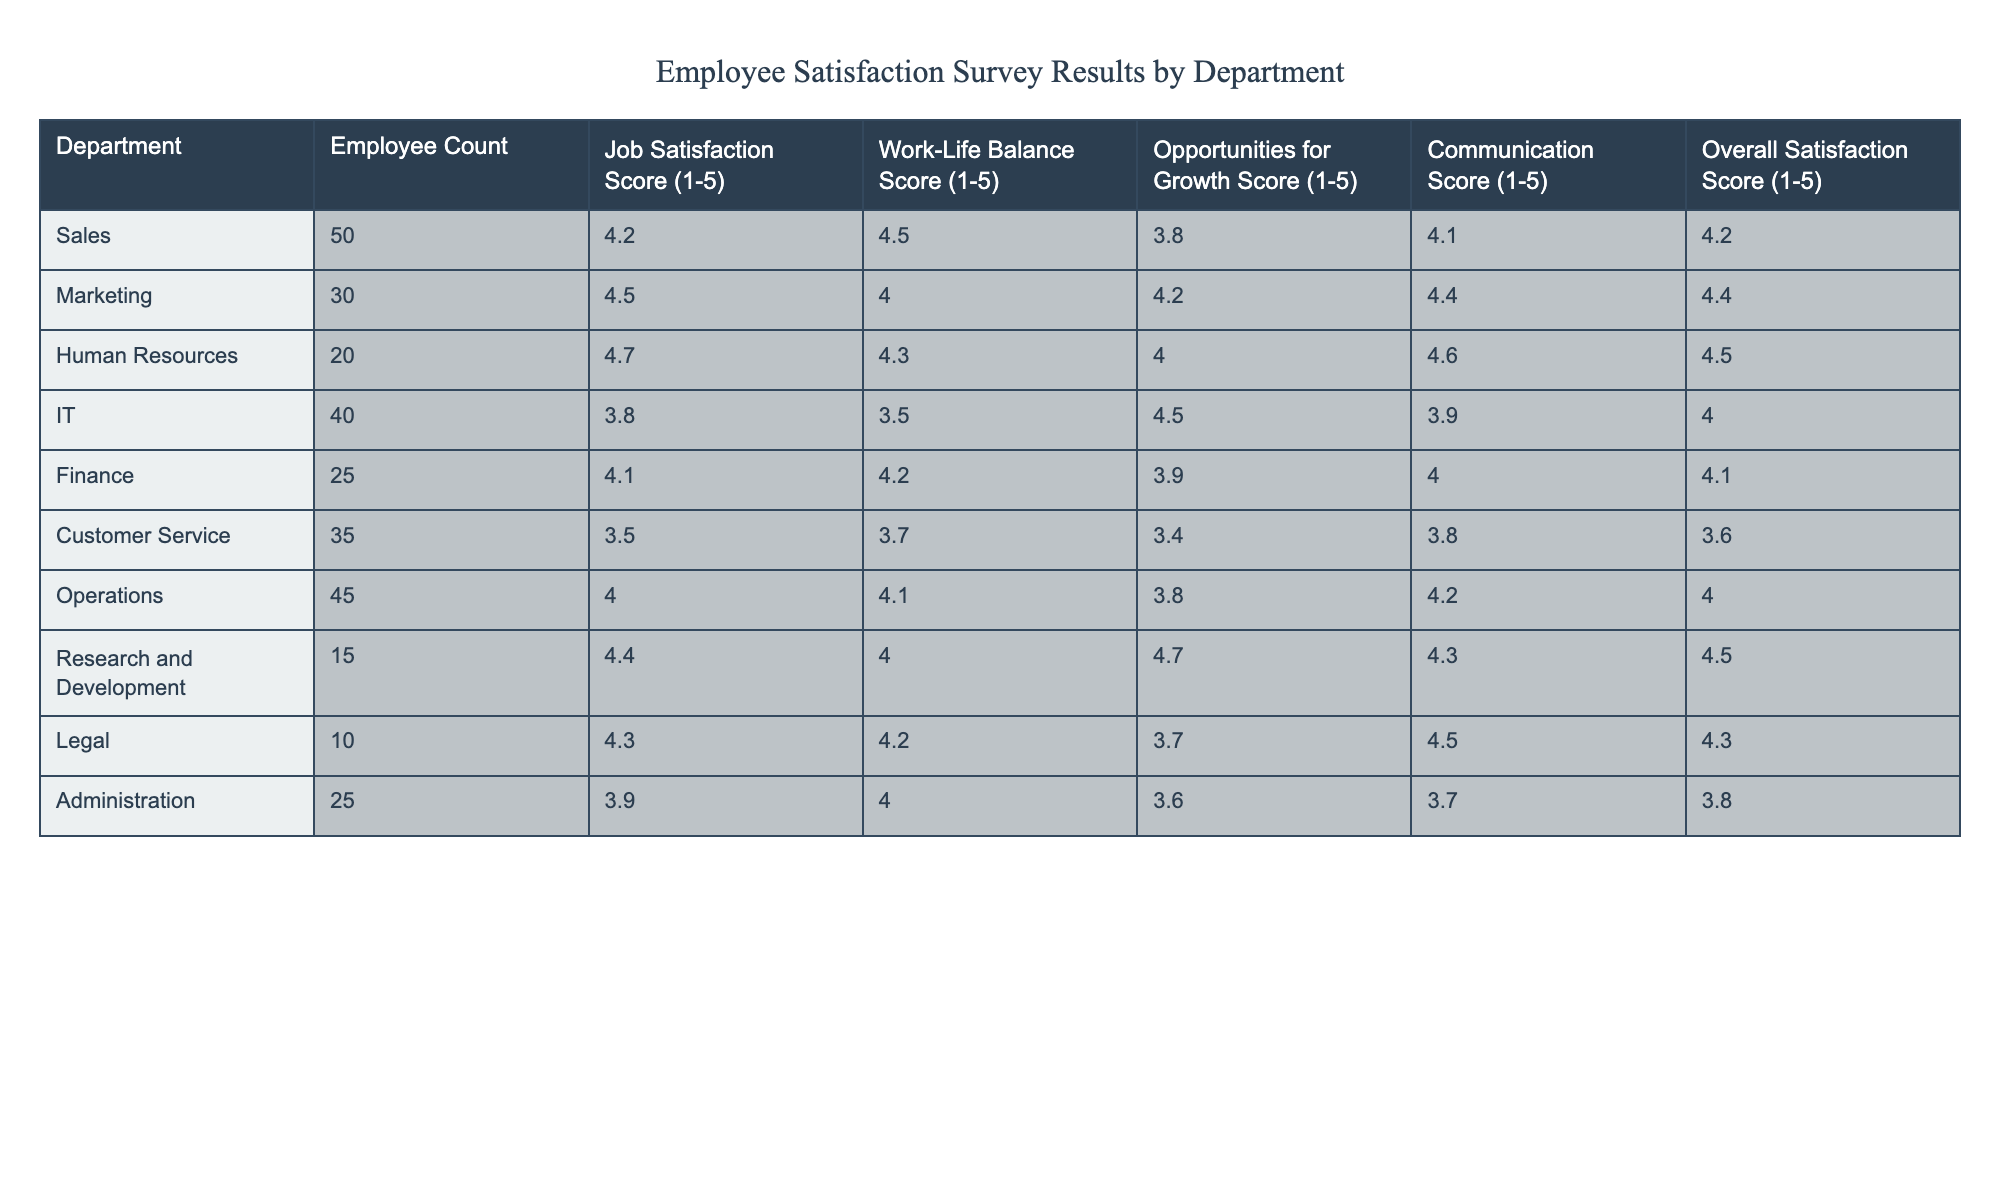What is the Job Satisfaction Score for the Human Resources department? The Job Satisfaction Score for Human Resources is found directly in the table under the corresponding column. It is clearly labeled and associated with the department's name.
Answer: 4.7 Which department has the highest Overall Satisfaction Score? By reviewing the Overall Satisfaction Score column, I can see the highest score listed is 4.5, which belongs to both Human Resources and Research and Development.
Answer: Human Resources and Research and Development What is the difference between the Work-Life Balance Score for Sales and Customer Service? The Work-Life Balance Score for Sales is 4.5, and for Customer Service, it is 3.7. To find the difference, subtract the lower score from the higher score: 4.5 - 3.7 = 0.8.
Answer: 0.8 What is the average Opportunities for Growth Score across all departments? I add together all the Opportunities for Growth Scores: (3.8 + 4.2 + 4.0 + 4.5 + 3.9 + 3.4 + 3.8 + 4.7 + 3.7 + 3.6) = 37.6. Then, divide by the number of departments (10): 37.6 / 10 = 3.76.
Answer: 3.76 Does the IT department have a higher Communication Score than the Administration department? The Communication Score for IT is 3.9, while for Administration it is 3.7. Since 3.9 is greater than 3.7, this statement is true.
Answer: Yes What is the Overall Satisfaction Score for the department with the least number of employees? The department with the least number of employees is Legal, which has 10 employees. Referring to the table, the Overall Satisfaction Score for Legal is 4.3.
Answer: 4.3 Which department has a Job Satisfaction Score below 4.0? Looking through the Job Satisfaction Scores in the table, I see that only the IT department has a score below 4.0, which is 3.8.
Answer: IT Calculate the total employee count for departments with an Overall Satisfaction Score above 4.0. The departments with an Overall Satisfaction Score above 4.0 are Marketing (30), Human Resources (20), Research and Development (15), and Legal (10). Adding these counts gives: 30 + 20 + 15 + 10 = 75.
Answer: 75 Is the Communication Score for Marketing higher than that of Operations? The Communication Score for Marketing is 4.4, and for Operations, it is 4.2. Since 4.4 is greater than 4.2, this statement is true.
Answer: Yes What could be the implication of Customer Service having the lowest Overall Satisfaction Score? Customer Service's Overall Satisfaction Score is 3.6, which is the lowest among all departments. This could indicate potential issues with employee morale or effectiveness in communication within the department.
Answer: Potential morale or communication issues 